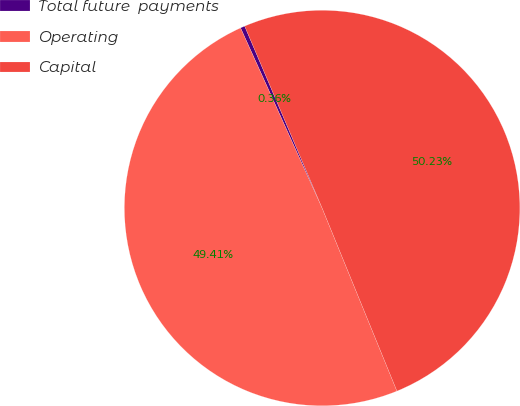Convert chart. <chart><loc_0><loc_0><loc_500><loc_500><pie_chart><fcel>Total future  payments<fcel>Operating<fcel>Capital<nl><fcel>0.36%<fcel>49.41%<fcel>50.23%<nl></chart> 